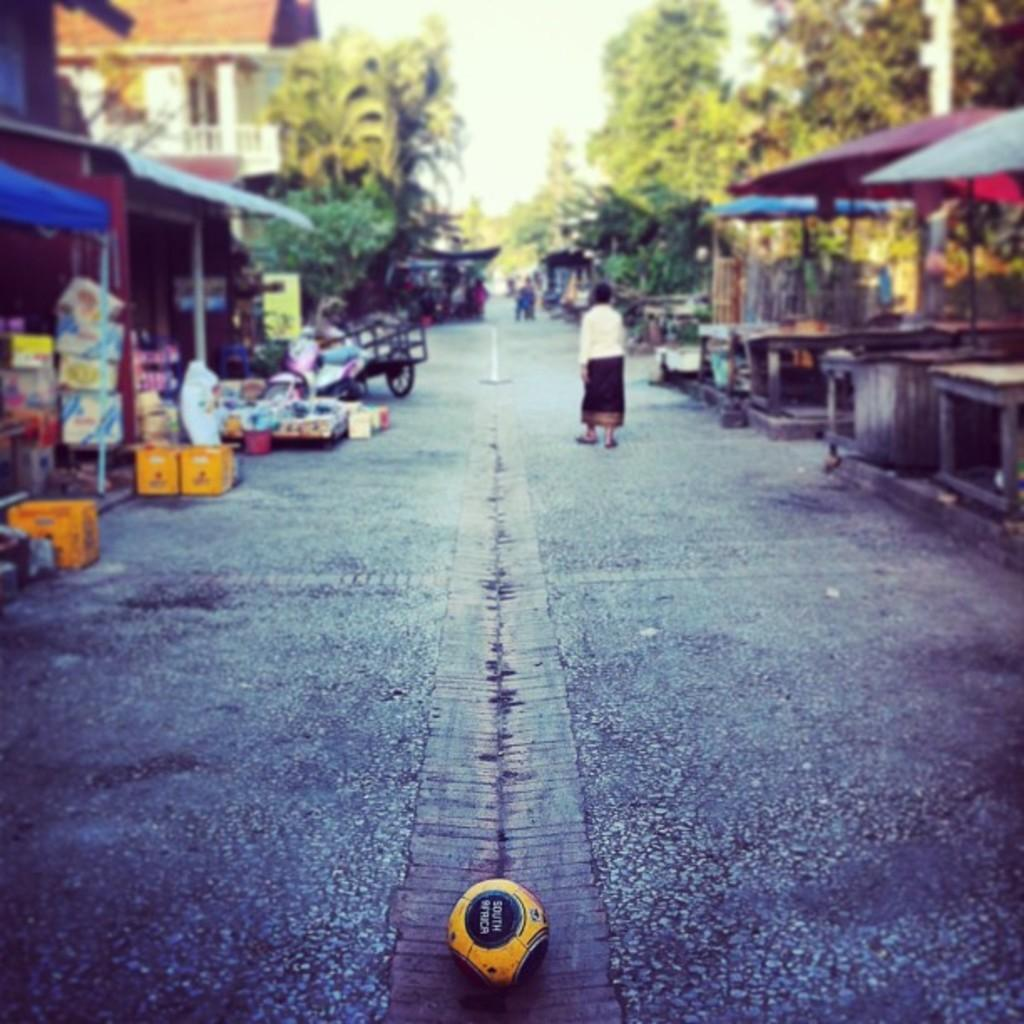What is the main subject of the image? There is a person walking on the road in the image. What can be seen in the background of the image? There are trees and houses in the background of the image. What type of earth is being produced by the person in the image? There is no indication in the image that the person is producing any type of earth. 